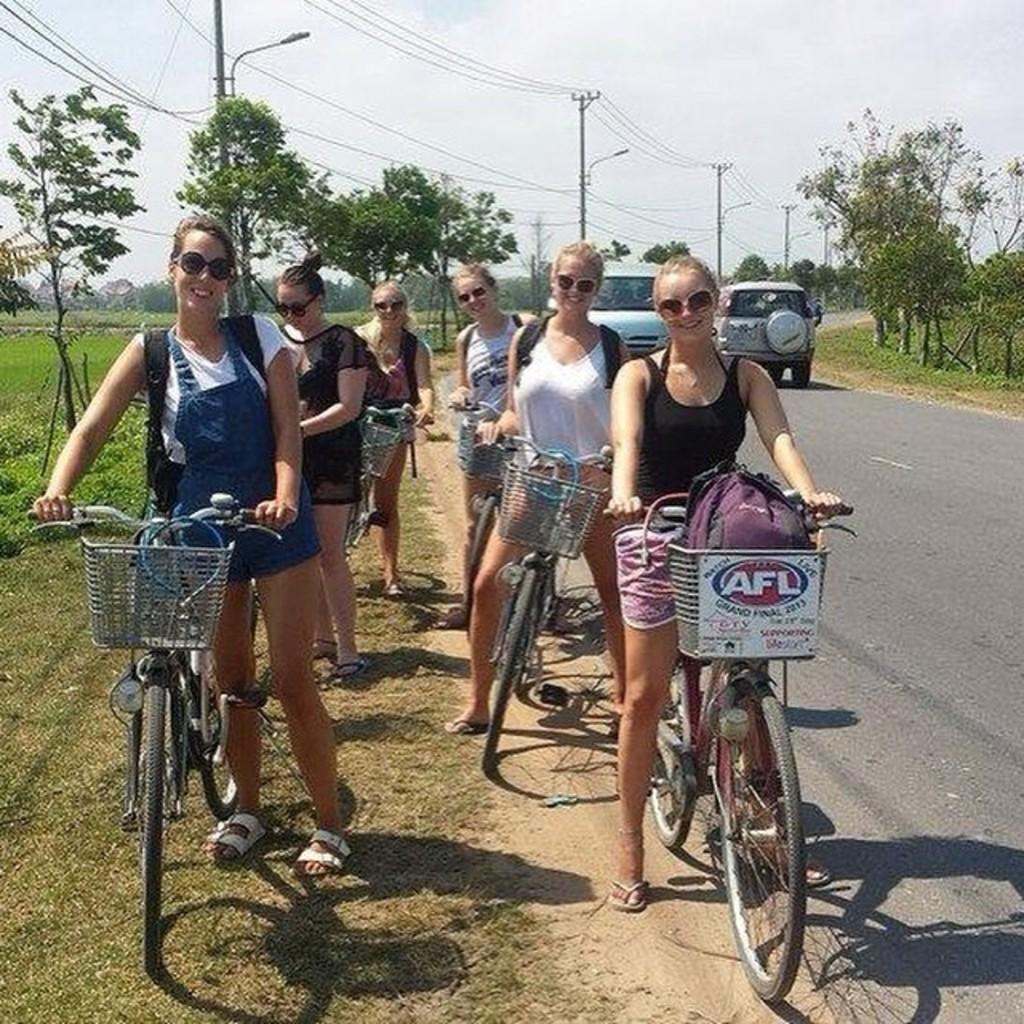Describe this image in one or two sentences. There are six girls in the picture and six of them are wearing goggles. These are the bicycles, vehicle and electric pole. There are many trees around and a white sky. 